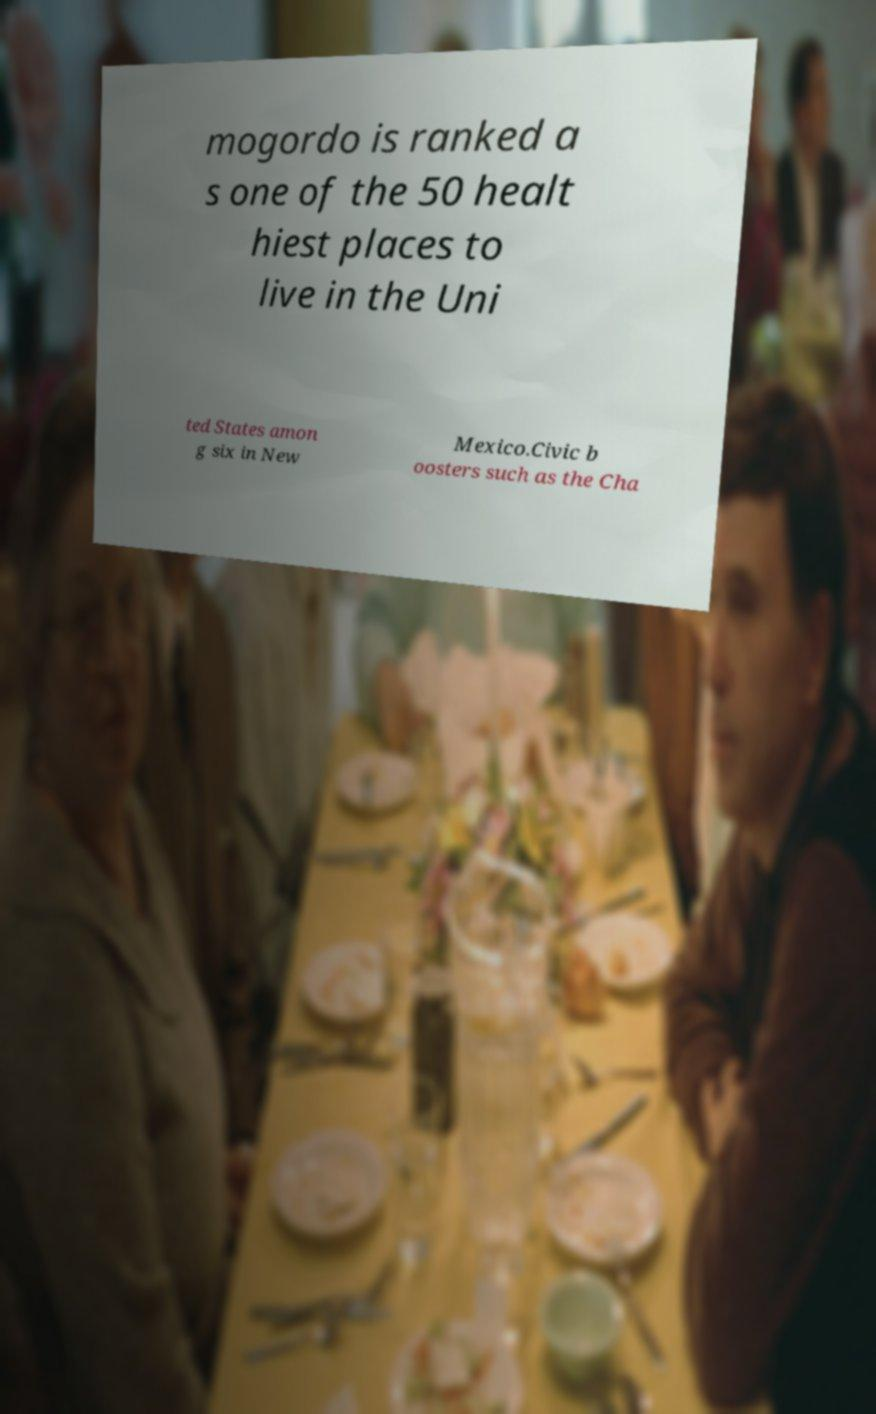There's text embedded in this image that I need extracted. Can you transcribe it verbatim? mogordo is ranked a s one of the 50 healt hiest places to live in the Uni ted States amon g six in New Mexico.Civic b oosters such as the Cha 